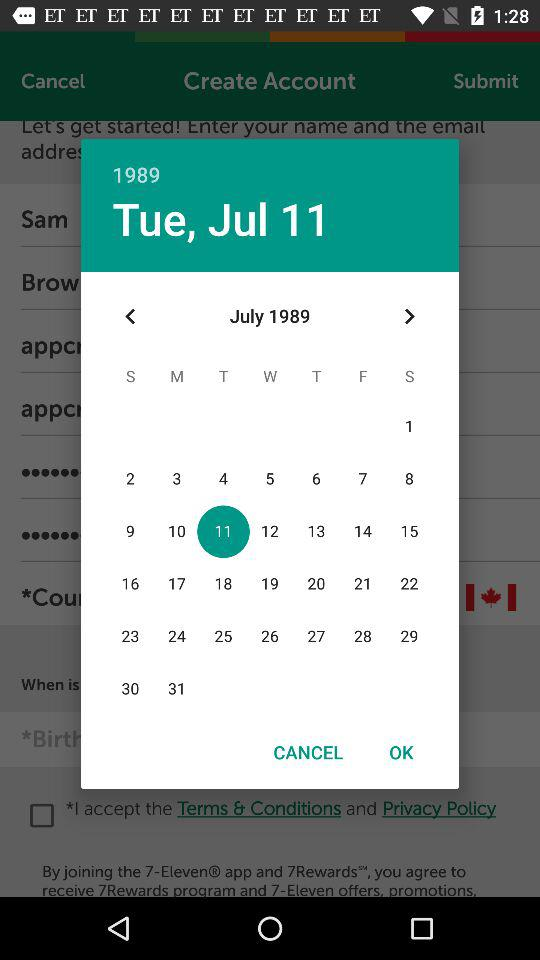What date has been selected? The date that has been selected is Tuesday, July 11, 1989. 